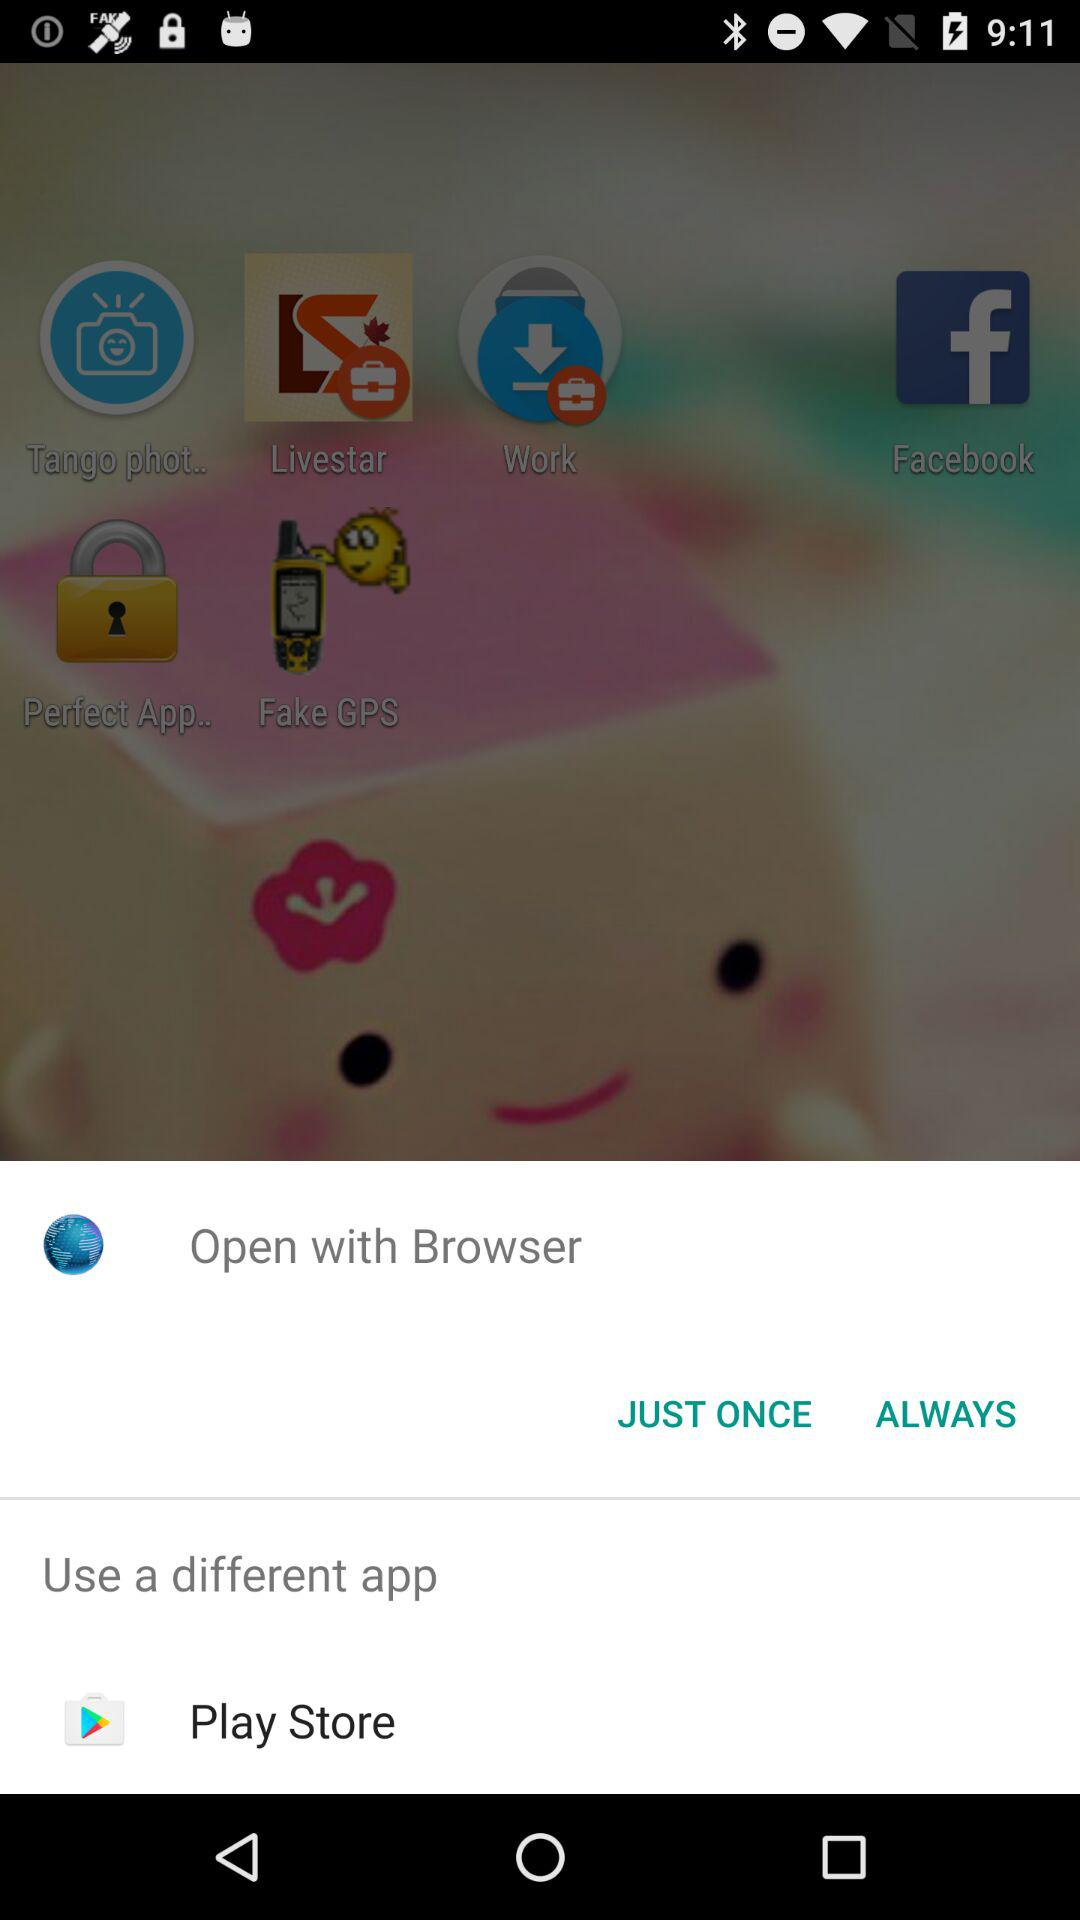What is the different app to use? The different app to use is "Play Store". 